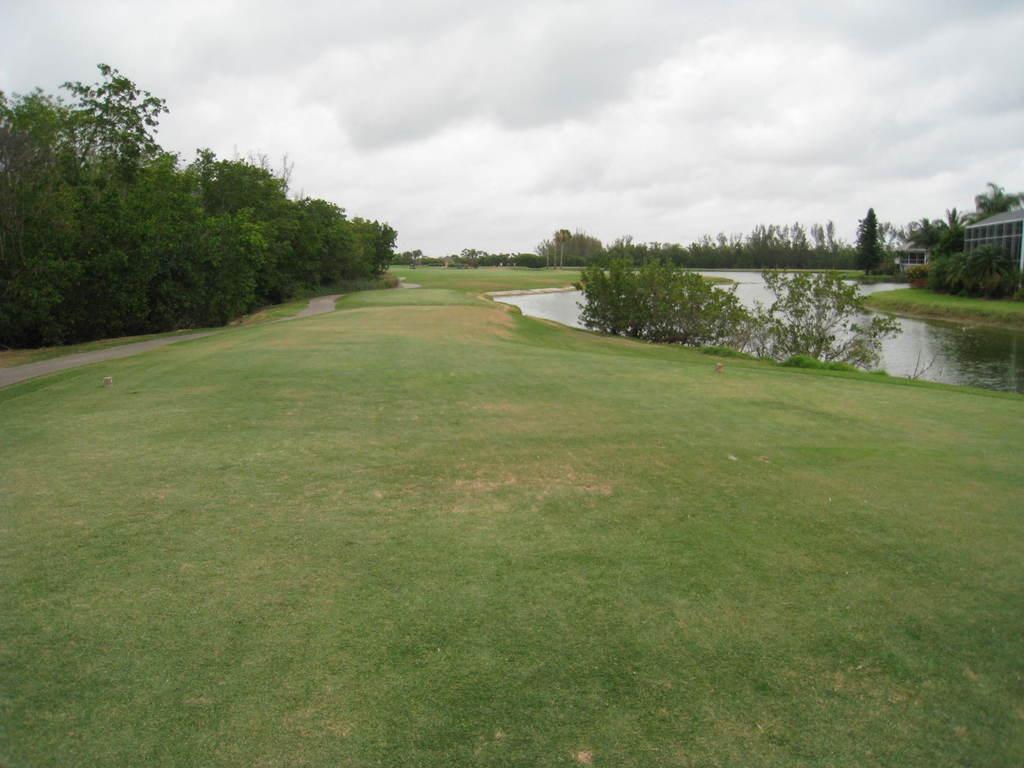Can you describe this image briefly? In this image I can see plants, the grass, the water and trees. Here I can see a building and the sky. 